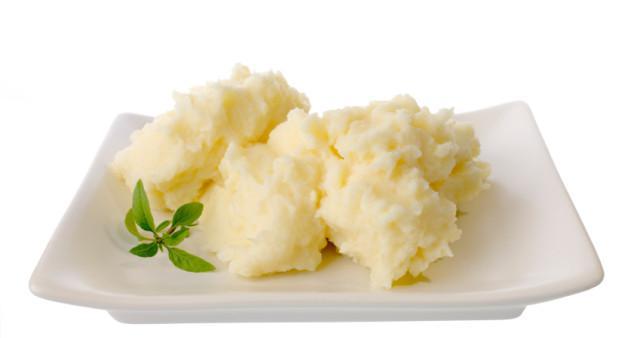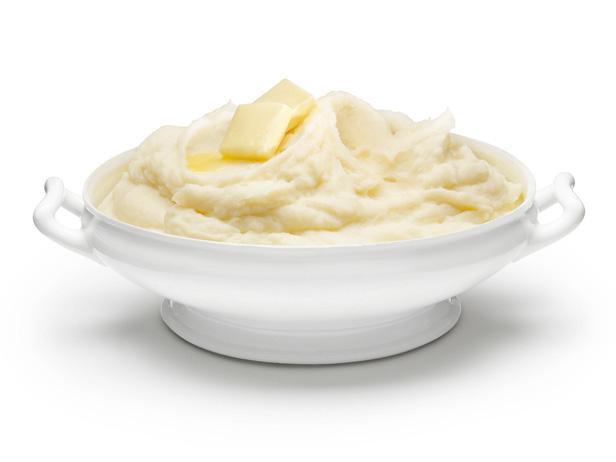The first image is the image on the left, the second image is the image on the right. Examine the images to the left and right. Is the description "One image shows mashed potatoes on a squarish plate garnished with green sprig." accurate? Answer yes or no. Yes. 